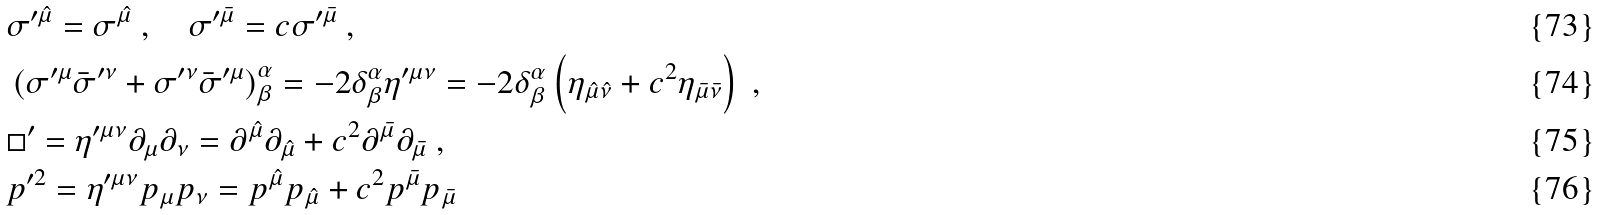<formula> <loc_0><loc_0><loc_500><loc_500>& \sigma ^ { \prime \hat { \mu } } = \sigma ^ { \hat { \mu } } \ , \quad \sigma ^ { \prime \bar { \mu } } = c \sigma ^ { \prime \bar { \mu } } \ , \\ & \left ( \sigma ^ { \prime \mu } \bar { \sigma } ^ { \prime \nu } + \sigma ^ { \prime \nu } \bar { \sigma } ^ { \prime \mu } \right ) ^ { \alpha } _ { \beta } = - 2 \delta ^ { \alpha } _ { \beta } \eta ^ { \prime \mu \nu } = - 2 \delta ^ { \alpha } _ { \beta } \left ( \eta _ { \hat { \mu } \hat { \nu } } + c ^ { 2 } \eta _ { \bar { \mu } \bar { \nu } } \right ) \ , \\ & { \Box } ^ { \prime } = \eta ^ { \prime \mu \nu } \partial _ { \mu } \partial _ { \nu } = \partial ^ { \hat { \mu } } \partial _ { \hat { \mu } } + c ^ { 2 } \partial ^ { \bar { \mu } } \partial _ { \bar { \mu } } \ , \\ & p ^ { \prime 2 } = \eta ^ { \prime \mu \nu } p _ { \mu } p _ { \nu } = p ^ { \hat { \mu } } p _ { \hat { \mu } } + c ^ { 2 } p ^ { \bar { \mu } } p _ { \bar { \mu } }</formula> 